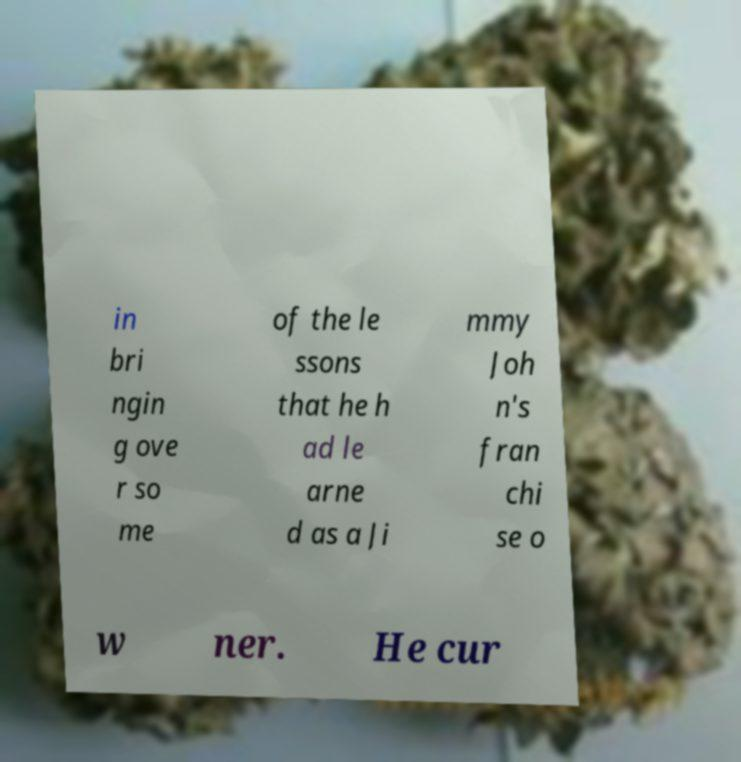There's text embedded in this image that I need extracted. Can you transcribe it verbatim? in bri ngin g ove r so me of the le ssons that he h ad le arne d as a Ji mmy Joh n's fran chi se o w ner. He cur 